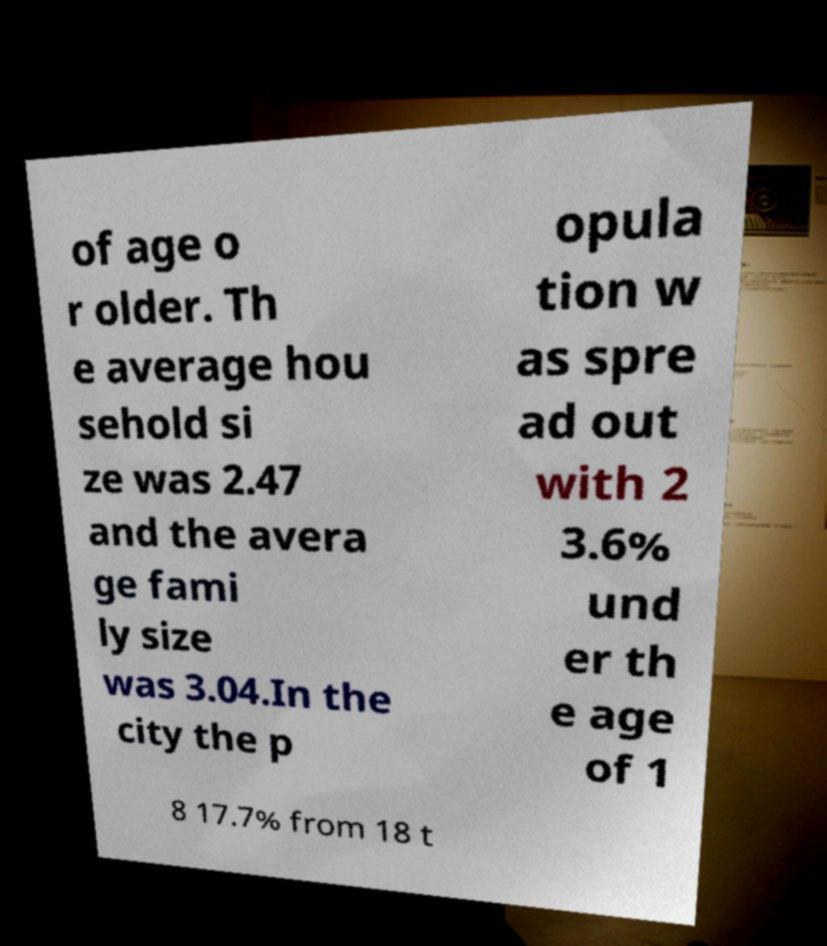Please identify and transcribe the text found in this image. of age o r older. Th e average hou sehold si ze was 2.47 and the avera ge fami ly size was 3.04.In the city the p opula tion w as spre ad out with 2 3.6% und er th e age of 1 8 17.7% from 18 t 